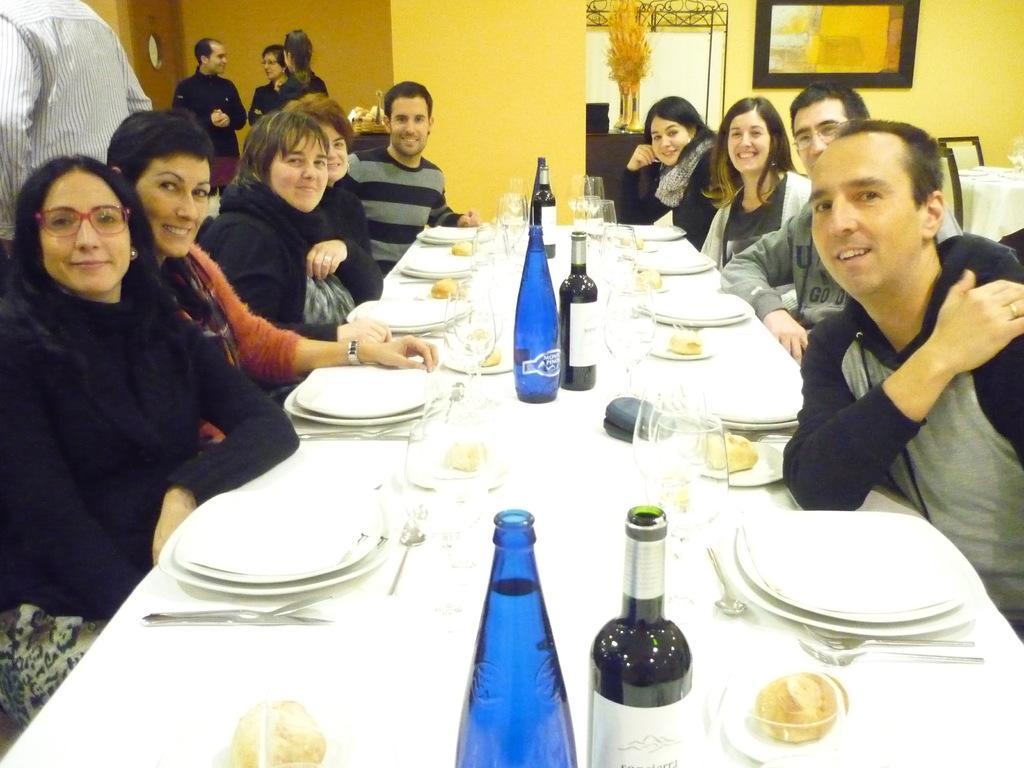Describe this image in one or two sentences. I can see a group of people sitting and smiling. This is the table covered with the cloth. I can see the plates, wine glasses, wine bottles, spoons, bowls and few other things on it. There are few people standing. This looks like a flower vase. Here is the frame, which is attached to the wall. I think this is the pillar. In the background, I can see another table covered with the cloth and these are the chairs. 